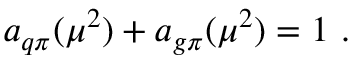<formula> <loc_0><loc_0><loc_500><loc_500>a _ { q \pi } ( \mu ^ { 2 } ) + a _ { g \pi } ( \mu ^ { 2 } ) = 1 \ .</formula> 